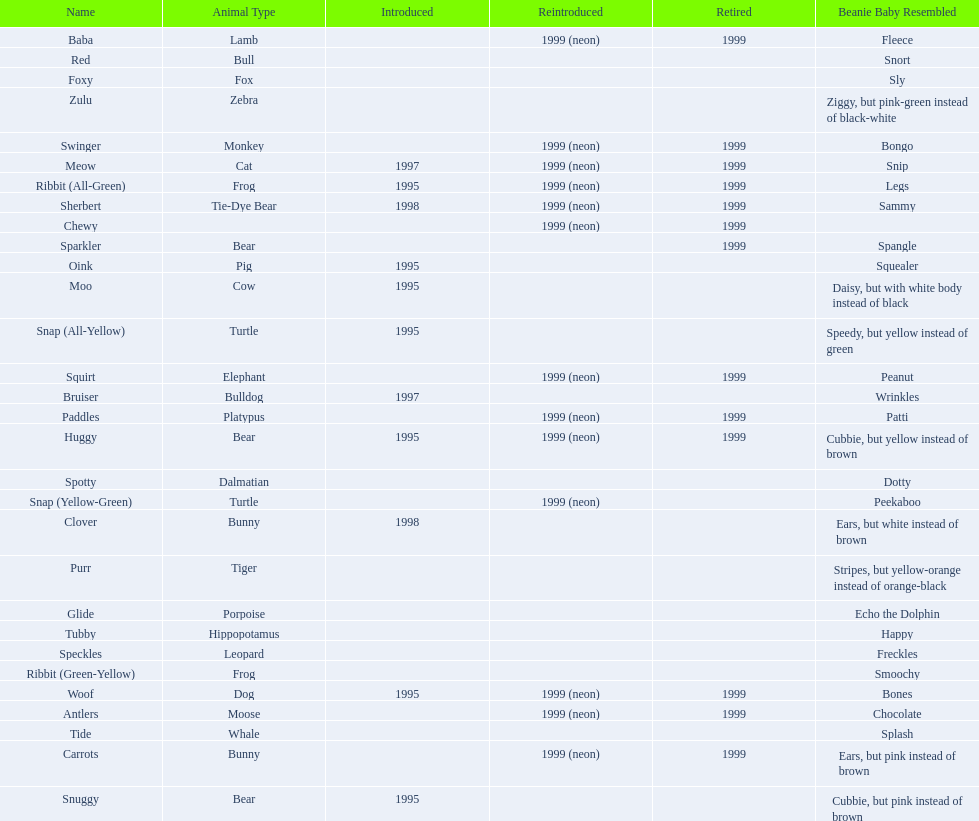What are all the different names of the pillow pals? Antlers, Baba, Bruiser, Carrots, Chewy, Clover, Foxy, Glide, Huggy, Meow, Moo, Oink, Paddles, Purr, Red, Ribbit (All-Green), Ribbit (Green-Yellow), Sherbert, Snap (All-Yellow), Snap (Yellow-Green), Snuggy, Sparkler, Speckles, Spotty, Squirt, Swinger, Tide, Tubby, Woof, Zulu. Which of these are a dalmatian? Spotty. 